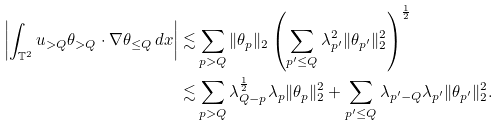<formula> <loc_0><loc_0><loc_500><loc_500>\left | \int _ { \mathbb { T } ^ { 2 } } u _ { > Q } \theta _ { > Q } \cdot \nabla \theta _ { \leq Q } \, d x \right | \lesssim & \sum _ { p > Q } \| \theta _ { p } \| _ { 2 } \left ( \sum _ { p ^ { \prime } \leq Q } \lambda _ { p ^ { \prime } } ^ { 2 } \| \theta _ { p ^ { \prime } } \| _ { 2 } ^ { 2 } \right ) ^ { \frac { 1 } { 2 } } \\ \lesssim & \sum _ { p > Q } \lambda _ { Q - p } ^ { \frac { 1 } { 2 } } \lambda _ { p } \| \theta _ { p } \| _ { 2 } ^ { 2 } + \sum _ { p ^ { \prime } \leq Q } \lambda _ { p ^ { \prime } - Q } \lambda _ { p ^ { \prime } } \| \theta _ { p ^ { \prime } } \| _ { 2 } ^ { 2 } .</formula> 